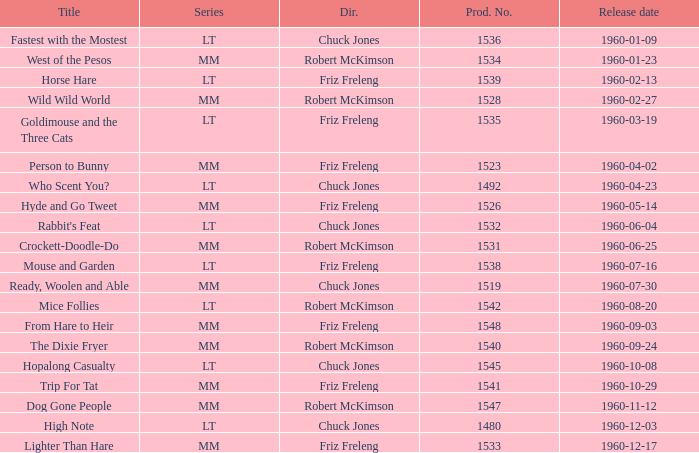What is the Series number of the episode with a production number of 1547? MM. Would you be able to parse every entry in this table? {'header': ['Title', 'Series', 'Dir.', 'Prod. No.', 'Release date'], 'rows': [['Fastest with the Mostest', 'LT', 'Chuck Jones', '1536', '1960-01-09'], ['West of the Pesos', 'MM', 'Robert McKimson', '1534', '1960-01-23'], ['Horse Hare', 'LT', 'Friz Freleng', '1539', '1960-02-13'], ['Wild Wild World', 'MM', 'Robert McKimson', '1528', '1960-02-27'], ['Goldimouse and the Three Cats', 'LT', 'Friz Freleng', '1535', '1960-03-19'], ['Person to Bunny', 'MM', 'Friz Freleng', '1523', '1960-04-02'], ['Who Scent You?', 'LT', 'Chuck Jones', '1492', '1960-04-23'], ['Hyde and Go Tweet', 'MM', 'Friz Freleng', '1526', '1960-05-14'], ["Rabbit's Feat", 'LT', 'Chuck Jones', '1532', '1960-06-04'], ['Crockett-Doodle-Do', 'MM', 'Robert McKimson', '1531', '1960-06-25'], ['Mouse and Garden', 'LT', 'Friz Freleng', '1538', '1960-07-16'], ['Ready, Woolen and Able', 'MM', 'Chuck Jones', '1519', '1960-07-30'], ['Mice Follies', 'LT', 'Robert McKimson', '1542', '1960-08-20'], ['From Hare to Heir', 'MM', 'Friz Freleng', '1548', '1960-09-03'], ['The Dixie Fryer', 'MM', 'Robert McKimson', '1540', '1960-09-24'], ['Hopalong Casualty', 'LT', 'Chuck Jones', '1545', '1960-10-08'], ['Trip For Tat', 'MM', 'Friz Freleng', '1541', '1960-10-29'], ['Dog Gone People', 'MM', 'Robert McKimson', '1547', '1960-11-12'], ['High Note', 'LT', 'Chuck Jones', '1480', '1960-12-03'], ['Lighter Than Hare', 'MM', 'Friz Freleng', '1533', '1960-12-17']]} 